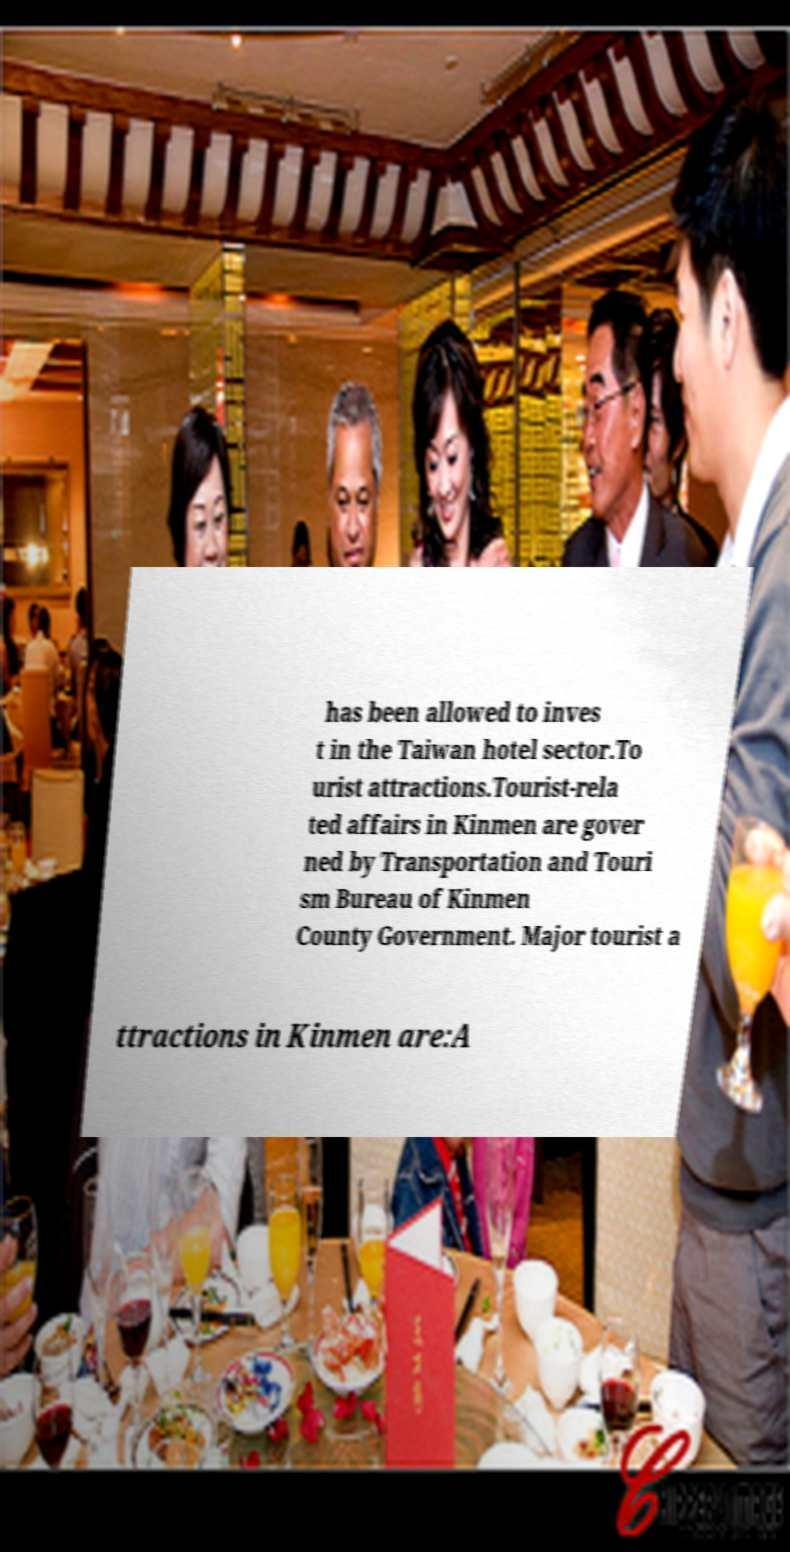Please read and relay the text visible in this image. What does it say? has been allowed to inves t in the Taiwan hotel sector.To urist attractions.Tourist-rela ted affairs in Kinmen are gover ned by Transportation and Touri sm Bureau of Kinmen County Government. Major tourist a ttractions in Kinmen are:A 